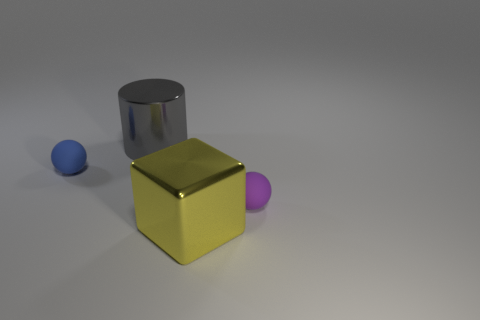Can you identify any potential uses or applications for the objects in the image? The objects in the image look like simple geometric shapes which can serve as educational tools for teaching geometry or used in various design and architectural visualization applications. They could also represent placeholders in a scene setup for testing lighting, materials, and rendering techniques in 3D software. 